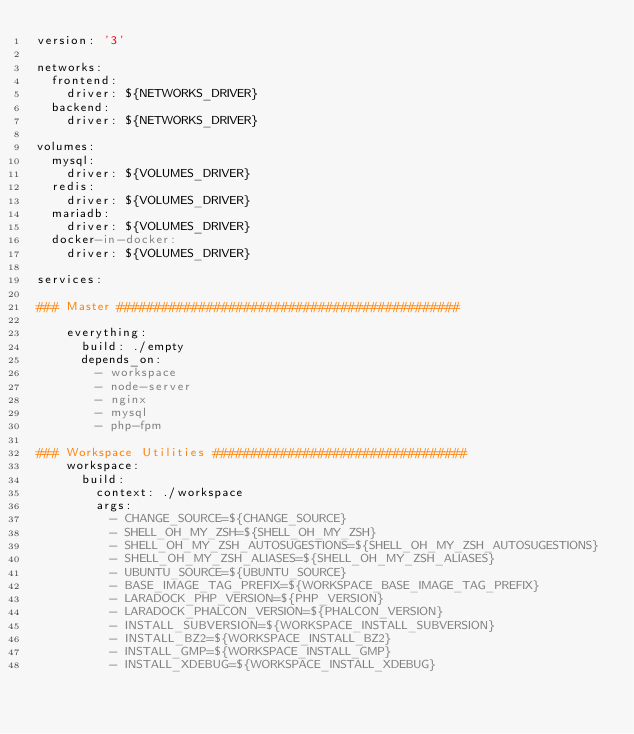<code> <loc_0><loc_0><loc_500><loc_500><_YAML_>version: '3'

networks:
  frontend:
    driver: ${NETWORKS_DRIVER}
  backend:
    driver: ${NETWORKS_DRIVER}

volumes:
  mysql:
    driver: ${VOLUMES_DRIVER}
  redis:
    driver: ${VOLUMES_DRIVER}
  mariadb:
    driver: ${VOLUMES_DRIVER}
  docker-in-docker:
    driver: ${VOLUMES_DRIVER}

services:

### Master ##############################################

    everything:
      build: ./empty
      depends_on:
        - workspace
        - node-server
        - nginx
        - mysql
        - php-fpm

### Workspace Utilities ##################################
    workspace:
      build:
        context: ./workspace
        args:
          - CHANGE_SOURCE=${CHANGE_SOURCE}
          - SHELL_OH_MY_ZSH=${SHELL_OH_MY_ZSH}
          - SHELL_OH_MY_ZSH_AUTOSUGESTIONS=${SHELL_OH_MY_ZSH_AUTOSUGESTIONS}
          - SHELL_OH_MY_ZSH_ALIASES=${SHELL_OH_MY_ZSH_ALIASES}
          - UBUNTU_SOURCE=${UBUNTU_SOURCE}
          - BASE_IMAGE_TAG_PREFIX=${WORKSPACE_BASE_IMAGE_TAG_PREFIX}
          - LARADOCK_PHP_VERSION=${PHP_VERSION}
          - LARADOCK_PHALCON_VERSION=${PHALCON_VERSION}
          - INSTALL_SUBVERSION=${WORKSPACE_INSTALL_SUBVERSION}
          - INSTALL_BZ2=${WORKSPACE_INSTALL_BZ2}
          - INSTALL_GMP=${WORKSPACE_INSTALL_GMP}
          - INSTALL_XDEBUG=${WORKSPACE_INSTALL_XDEBUG}</code> 